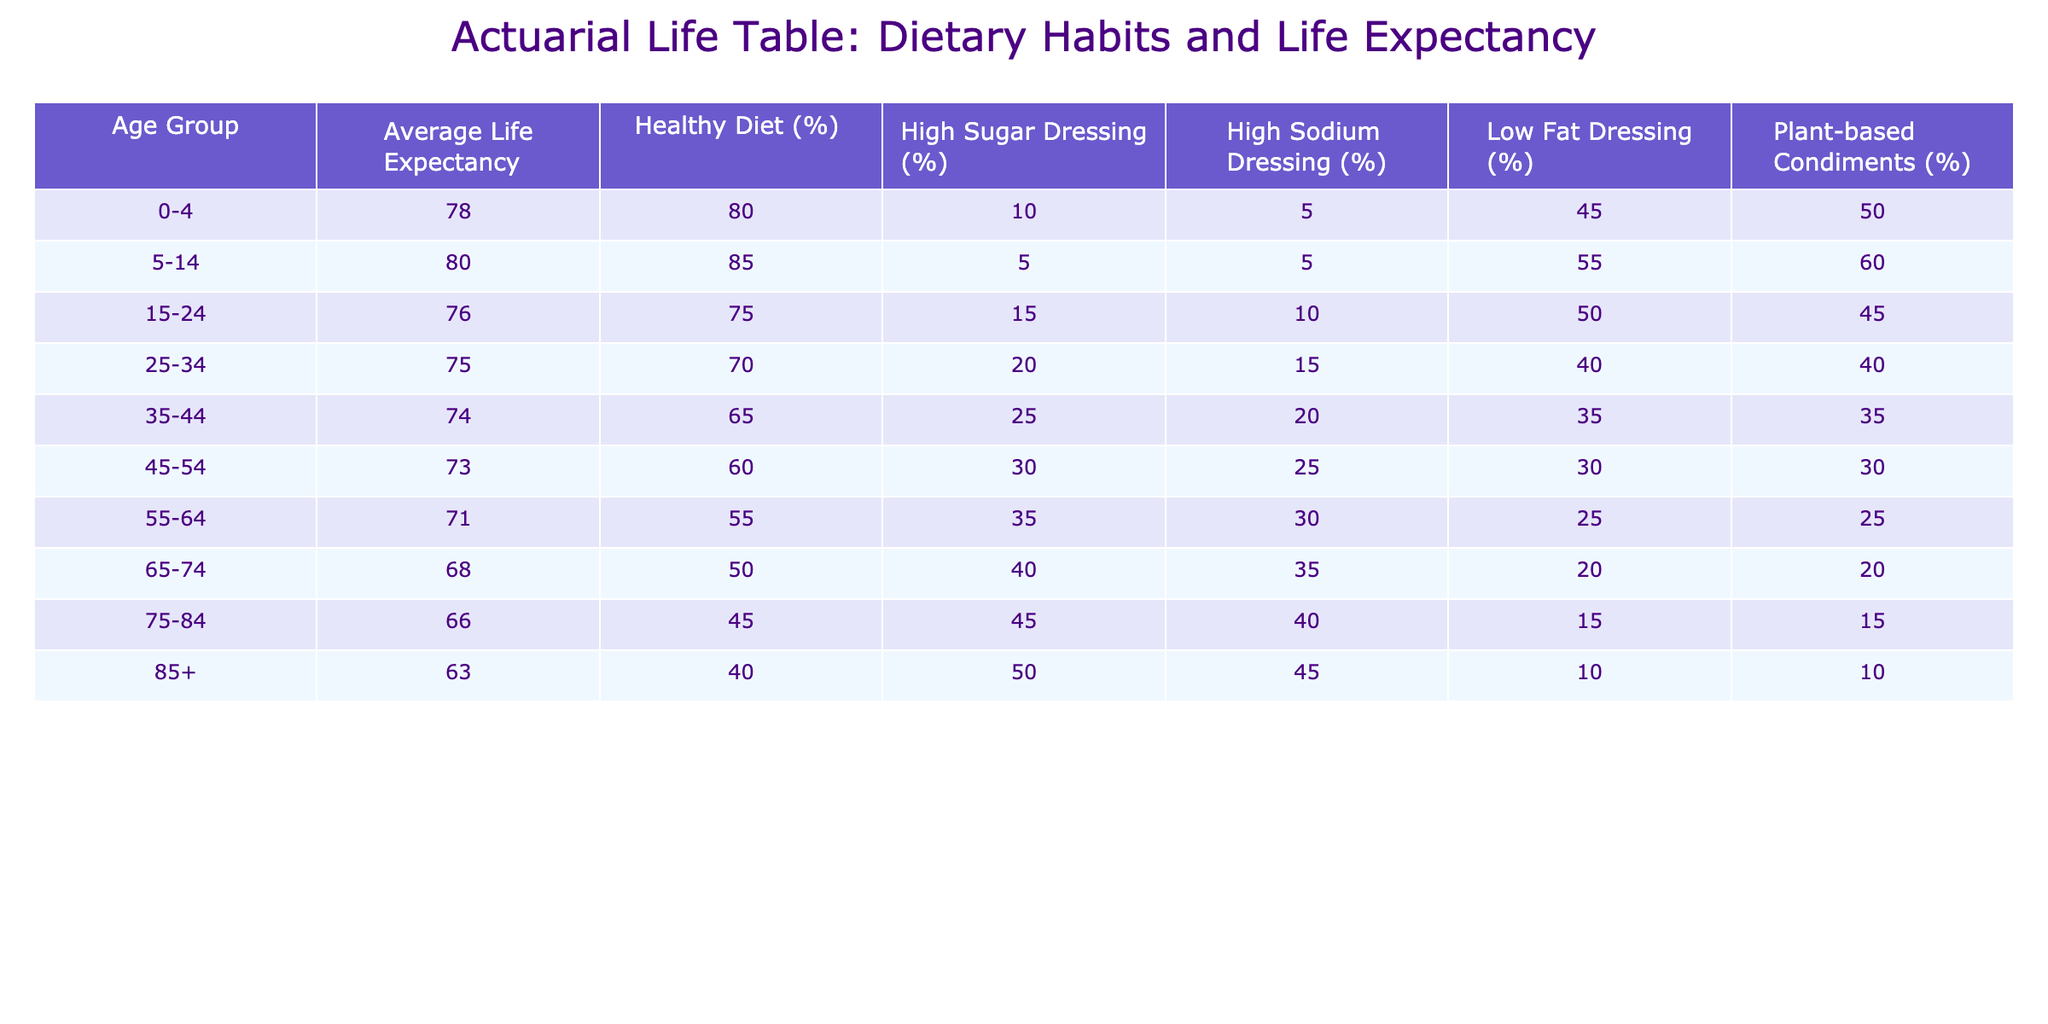What is the average life expectancy for the age group 55-64? The table lists the average life expectancy for the age group 55-64 as 71 years.
Answer: 71 Which age group has the highest percentage of individuals consuming a healthy diet? Referring to the table, the age group 5-14 has the highest percentage of individuals consuming a healthy diet at 85%.
Answer: 5-14 Is it true that individuals aged 85 and older consume a higher percentage of high sugar dressings compared to those aged 75-84? The table shows that 50% of individuals aged 85+ consume high sugar dressings, while 45% of those aged 75-84 do. Therefore, it is true.
Answer: Yes What is the difference in average life expectancy between individuals consuming high sodium dressings and low fat dressings in the age group 45-54? Individuals in the 45-54 age group have an average life expectancy of 73 years. Those consuming high sodium dressings (25%) have lower life expectancy (30%), while those consuming low fat dressings (30%) have a similar life expectancy. However, the average life expectancy does not differ based on these dressing types directly.
Answer: 0 If you consider the average life expectancy of individuals consuming low fat dressings in the age group 25-34 and compare it with those in the age group 35-44, what is the average of these two values? From the table, the average life expectancy for those consuming low fat dressings in the age group 25-34 is 75 years and in the age group 35-44 it is 74 years. The average of these two values is (75 + 74) / 2 = 74.5.
Answer: 74.5 Which age group has the lowest percentage of plant-based condiments consumption? The table indicates that individuals aged 85 and older have the lowest percentage of plant-based condiments consumption at 10%.
Answer: 85+ Is it true that the average life expectancy decreases with an increase in the percentage of high sodium dressings across the age groups? By analyzing the table, the average life expectancy decreases as the percentage of high sodium dressings increases across the different age groups. This trend confirms the statement as true.
Answer: Yes What is the average life expectancy of individuals aged 65-74 who consume high sugar dressings? Individuals aged 65-74 have an average life expectancy of 68 years regardless of dressing consumption, since the table does not break down life expectancy further by sugar dressing among this specific age group.
Answer: 68 